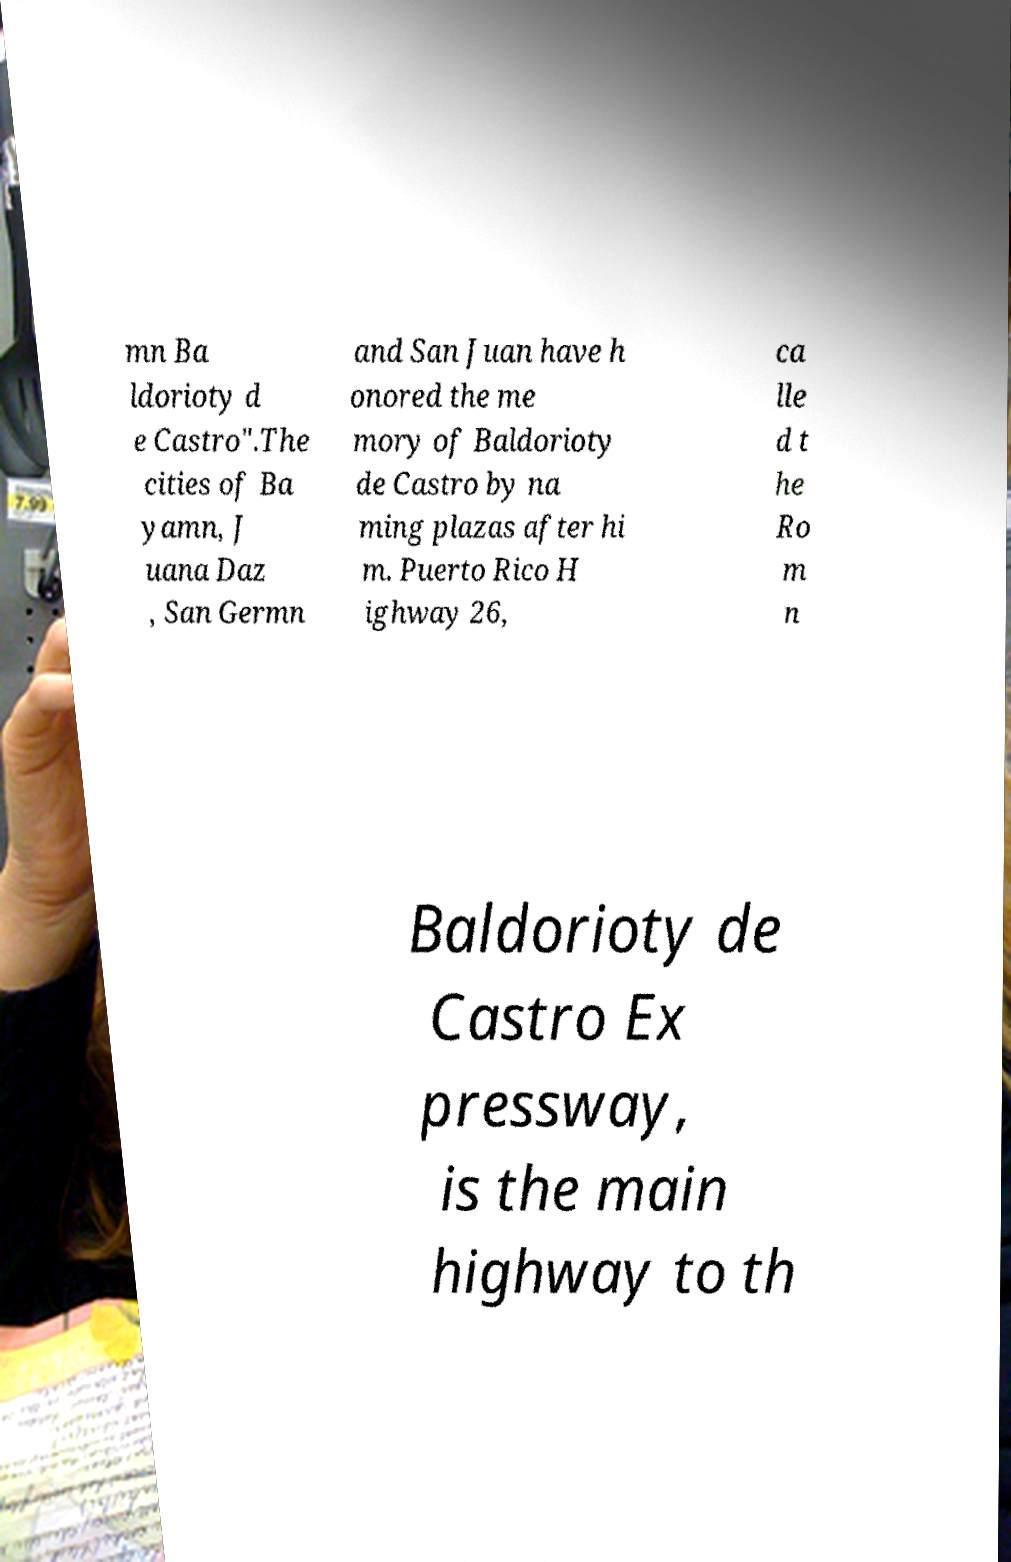Please identify and transcribe the text found in this image. mn Ba ldorioty d e Castro".The cities of Ba yamn, J uana Daz , San Germn and San Juan have h onored the me mory of Baldorioty de Castro by na ming plazas after hi m. Puerto Rico H ighway 26, ca lle d t he Ro m n Baldorioty de Castro Ex pressway, is the main highway to th 